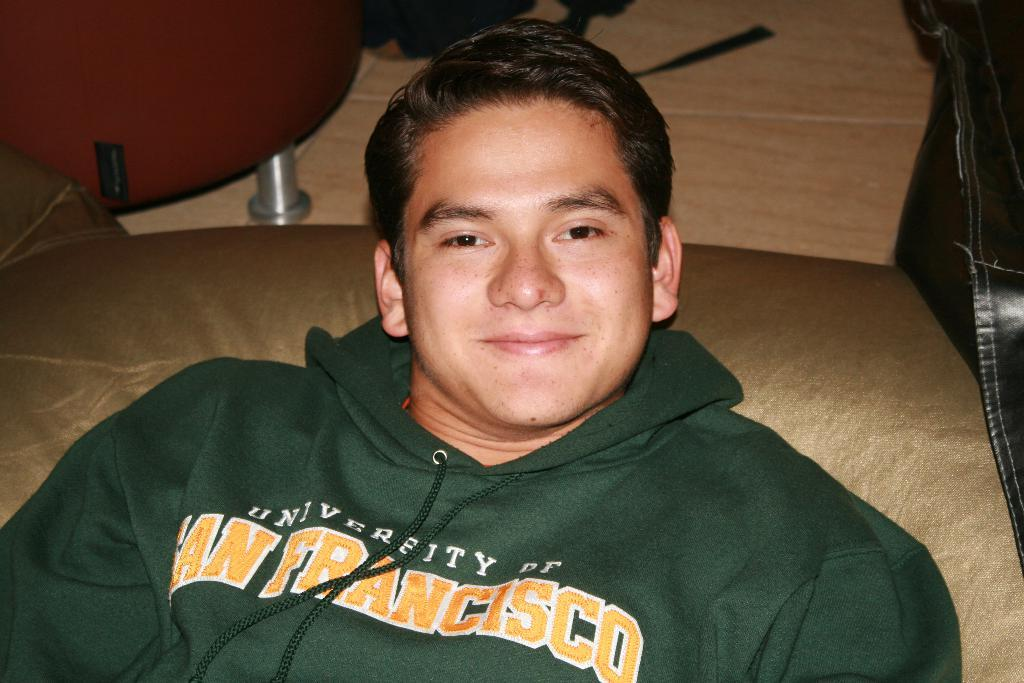<image>
Provide a brief description of the given image. A young man in a San Francisco sweatshirt reclines and smiles at the camera. 